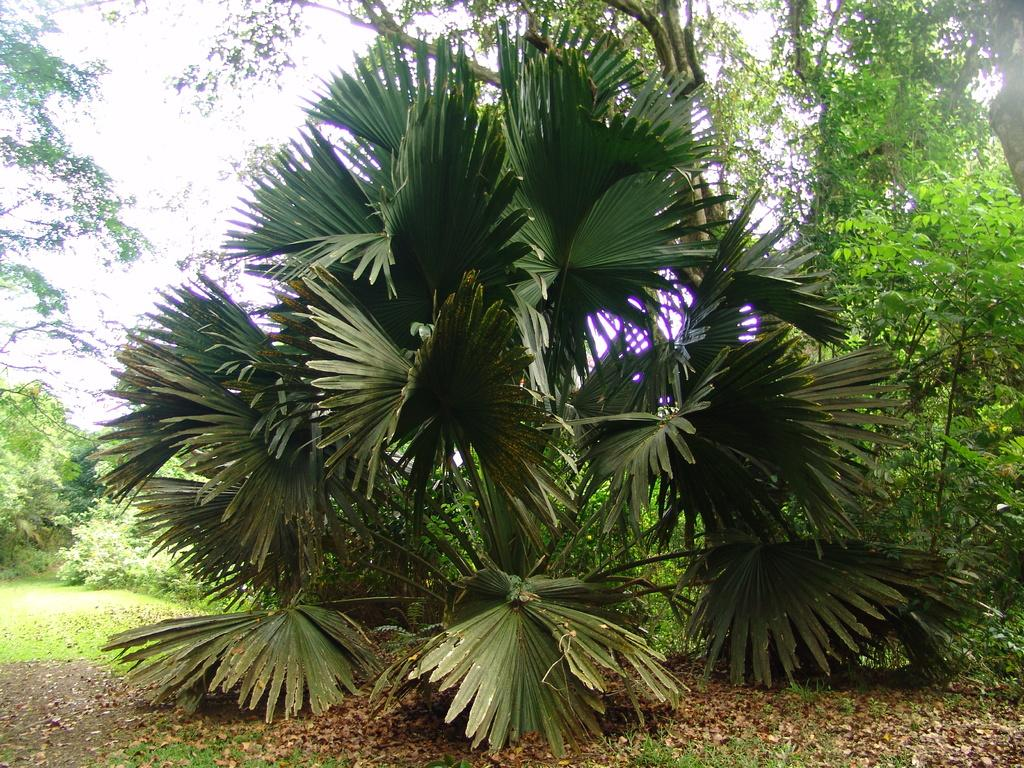What type of vegetation is present in the image? There are trees in the image. What type of ground cover can be seen in the image? There is grass on the surface in the image. What part of the natural environment is visible in the background of the image? The sky is visible in the background of the image. What type of wine is being served in harmony with the trees in the image? There is no wine or any indication of a gathering or event in the image; it simply features trees, grass, and the sky. 